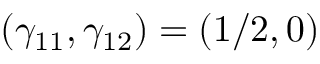<formula> <loc_0><loc_0><loc_500><loc_500>( \gamma _ { 1 1 } , \gamma _ { 1 2 } ) = ( 1 / 2 , 0 )</formula> 